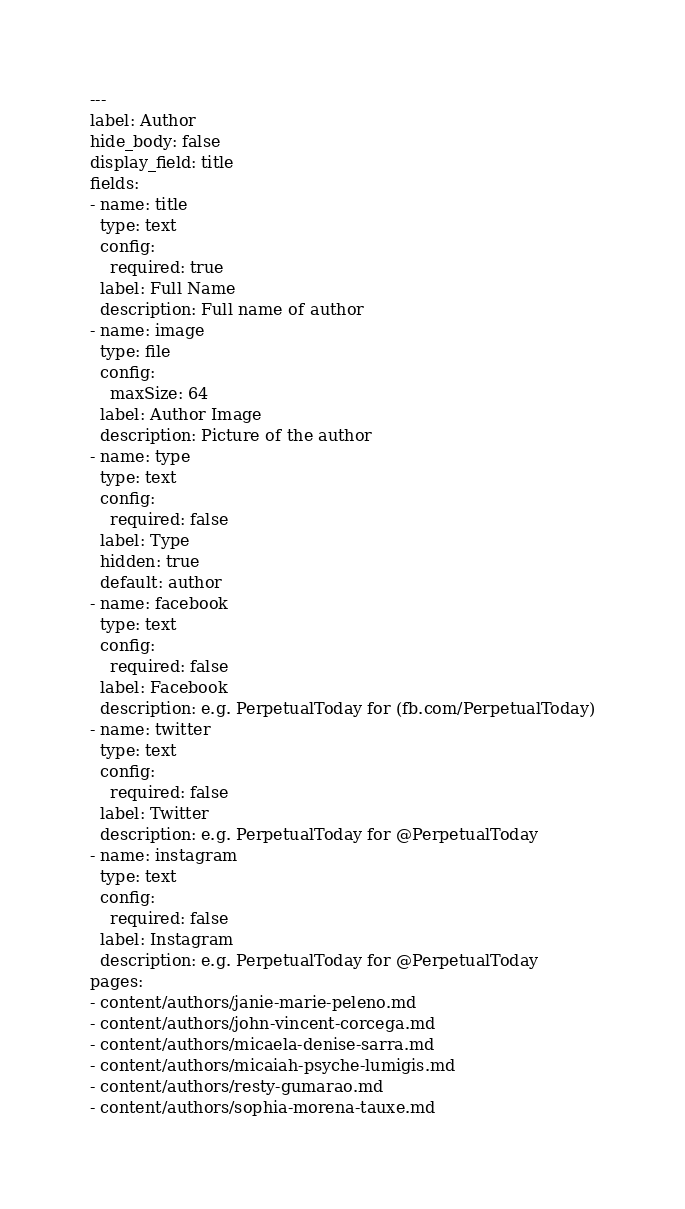Convert code to text. <code><loc_0><loc_0><loc_500><loc_500><_YAML_>---
label: Author
hide_body: false
display_field: title
fields:
- name: title
  type: text
  config:
    required: true
  label: Full Name
  description: Full name of author
- name: image
  type: file
  config:
    maxSize: 64
  label: Author Image
  description: Picture of the author
- name: type
  type: text
  config:
    required: false
  label: Type
  hidden: true
  default: author
- name: facebook
  type: text
  config:
    required: false
  label: Facebook
  description: e.g. PerpetualToday for (fb.com/PerpetualToday)
- name: twitter
  type: text
  config:
    required: false
  label: Twitter
  description: e.g. PerpetualToday for @PerpetualToday
- name: instagram
  type: text
  config:
    required: false
  label: Instagram
  description: e.g. PerpetualToday for @PerpetualToday
pages:
- content/authors/janie-marie-peleno.md
- content/authors/john-vincent-corcega.md
- content/authors/micaela-denise-sarra.md
- content/authors/micaiah-psyche-lumigis.md
- content/authors/resty-gumarao.md
- content/authors/sophia-morena-tauxe.md
</code> 